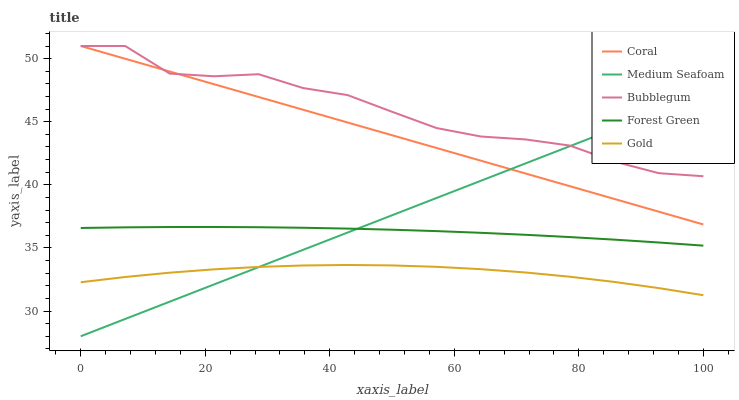Does Gold have the minimum area under the curve?
Answer yes or no. Yes. Does Bubblegum have the maximum area under the curve?
Answer yes or no. Yes. Does Coral have the minimum area under the curve?
Answer yes or no. No. Does Coral have the maximum area under the curve?
Answer yes or no. No. Is Coral the smoothest?
Answer yes or no. Yes. Is Bubblegum the roughest?
Answer yes or no. Yes. Is Gold the smoothest?
Answer yes or no. No. Is Gold the roughest?
Answer yes or no. No. Does Gold have the lowest value?
Answer yes or no. No. Does Bubblegum have the highest value?
Answer yes or no. Yes. Does Gold have the highest value?
Answer yes or no. No. Is Forest Green less than Bubblegum?
Answer yes or no. Yes. Is Bubblegum greater than Forest Green?
Answer yes or no. Yes. Does Medium Seafoam intersect Bubblegum?
Answer yes or no. Yes. Is Medium Seafoam less than Bubblegum?
Answer yes or no. No. Is Medium Seafoam greater than Bubblegum?
Answer yes or no. No. Does Forest Green intersect Bubblegum?
Answer yes or no. No. 